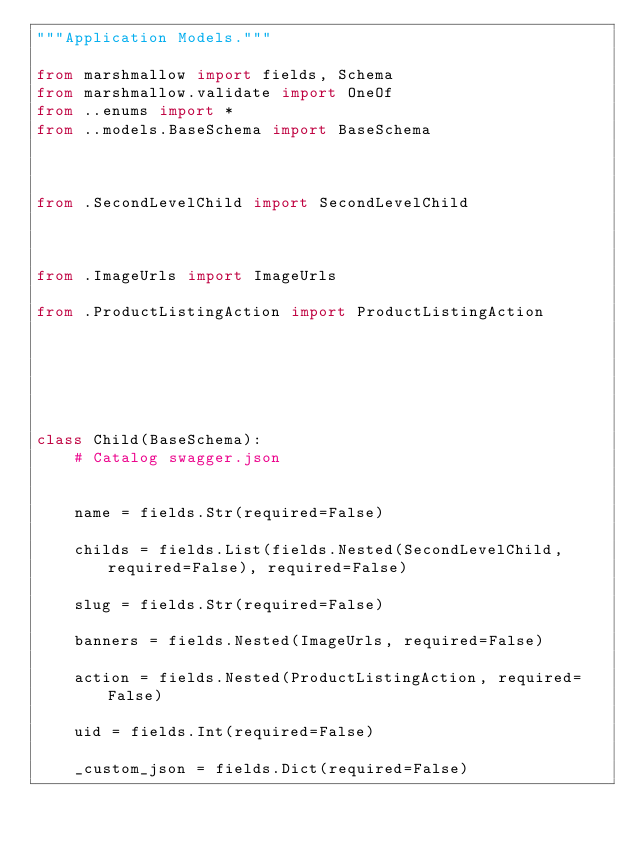Convert code to text. <code><loc_0><loc_0><loc_500><loc_500><_Python_>"""Application Models."""

from marshmallow import fields, Schema
from marshmallow.validate import OneOf
from ..enums import *
from ..models.BaseSchema import BaseSchema



from .SecondLevelChild import SecondLevelChild



from .ImageUrls import ImageUrls

from .ProductListingAction import ProductListingAction






class Child(BaseSchema):
    # Catalog swagger.json

    
    name = fields.Str(required=False)
    
    childs = fields.List(fields.Nested(SecondLevelChild, required=False), required=False)
    
    slug = fields.Str(required=False)
    
    banners = fields.Nested(ImageUrls, required=False)
    
    action = fields.Nested(ProductListingAction, required=False)
    
    uid = fields.Int(required=False)
    
    _custom_json = fields.Dict(required=False)
    

</code> 